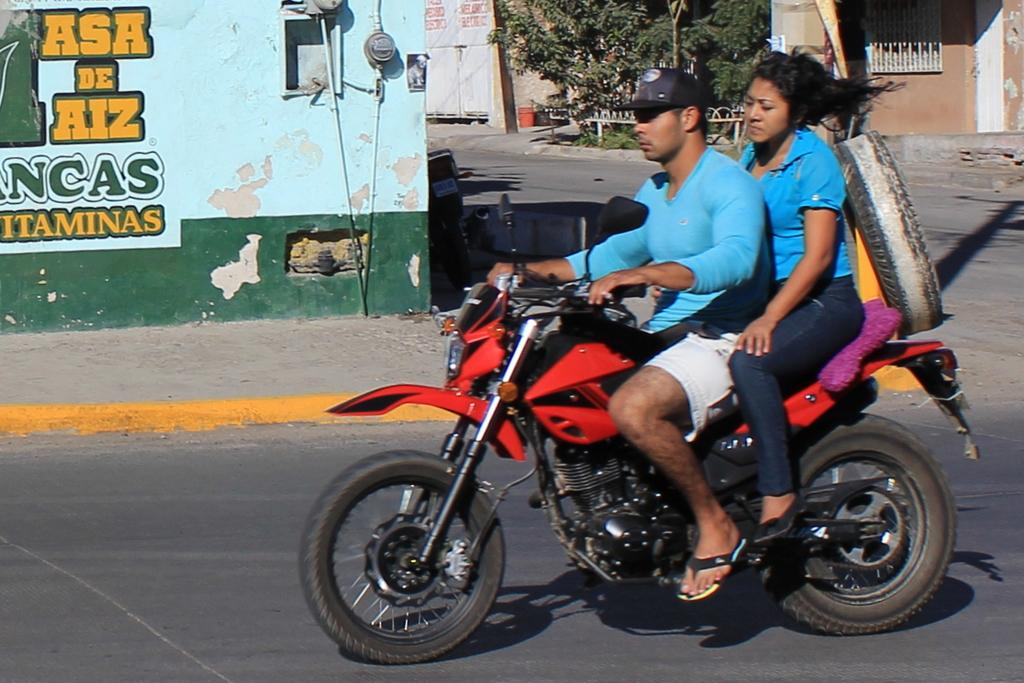What is the person in the image doing? The person is riding a bike in the image. What color is the bike? The bike is red. Who is with the person riding the bike? There is a lady sitting behind the person on the bike. What is the lady wearing? The lady is wearing a blue shirt. What can be seen on the wall beside them? There is something written on the wall beside them. What type of coach can be seen in the image? There is no coach present in the image; it features a person riding a bike with a lady sitting behind them. What type of poison is the person on the bike using to ride faster? There is no mention of poison in the image, and the person is riding a bike without any assistance. 